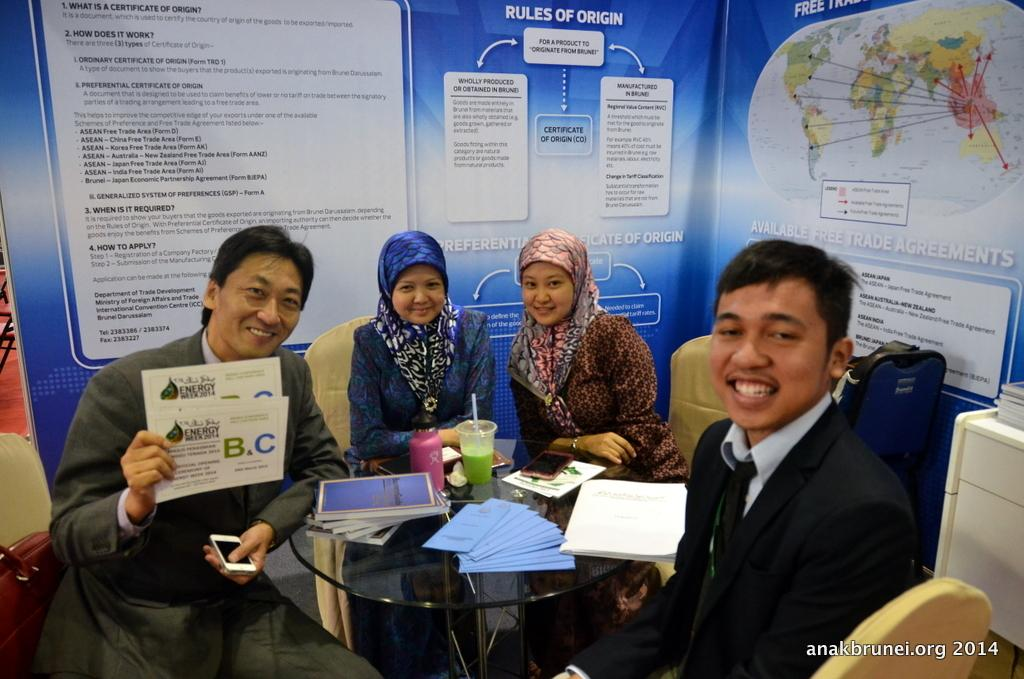How many people are in the image? There are 4 persons in the image. What are the persons doing in the image? The persons are sitting on chairs and laughing. How are the chairs arranged in the image? The chairs are arranged around a table. What can be seen behind the persons in the image? There are banners visible behind the persons. Can you see a window in the image? There is no window visible in the image. What type of birth is being celebrated in the image? There is no indication of a birth or any celebration in the image. 